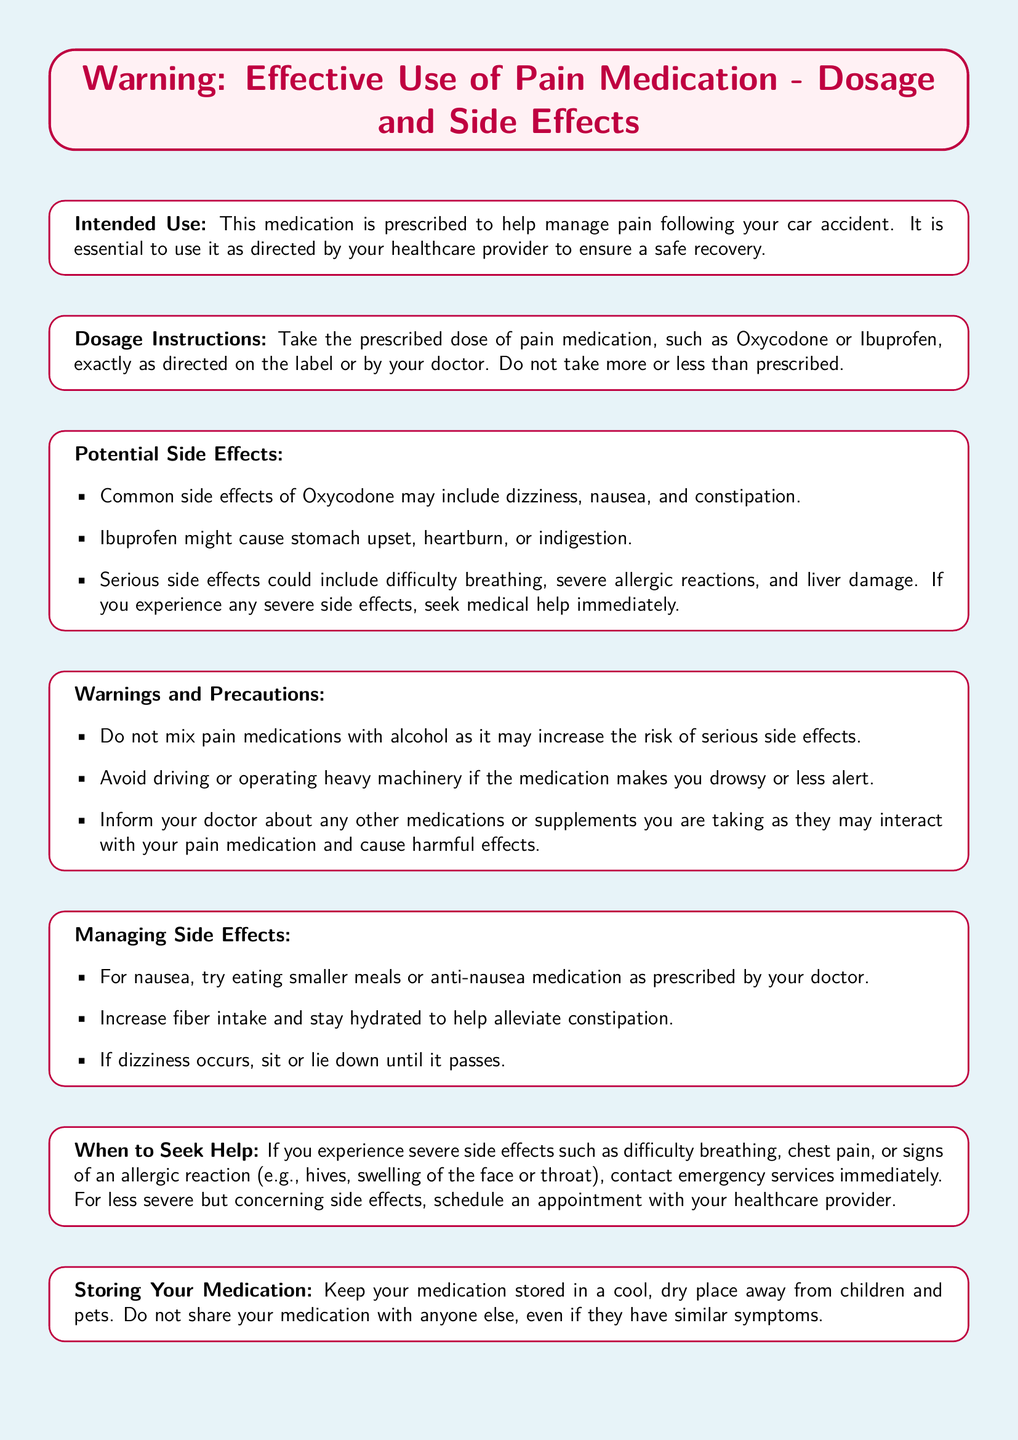What is the intended use of the medication? The intended use is to manage pain following a car accident.
Answer: Manage pain following a car accident What are two common side effects of Oxycodone? Common side effects mentioned for Oxycodone include dizziness and nausea.
Answer: Dizziness, nausea What should you avoid while taking pain medications? The document warns against mixing pain medications with alcohol.
Answer: Mixing with alcohol What is one way to manage nausea caused by the medication? The document suggests eating smaller meals or using anti-nausea medication as prescribed.
Answer: Eating smaller meals What action should you take if you experience difficulty breathing? The document states that you should contact emergency services immediately.
Answer: Contact emergency services 